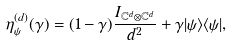<formula> <loc_0><loc_0><loc_500><loc_500>\eta _ { \psi } ^ { ( d ) } ( \gamma ) = ( 1 - \gamma ) \frac { I _ { \mathbb { C } ^ { d } \otimes \mathbb { C } ^ { d } } } { d ^ { 2 } } + \gamma | \psi \rangle \langle \psi | ,</formula> 